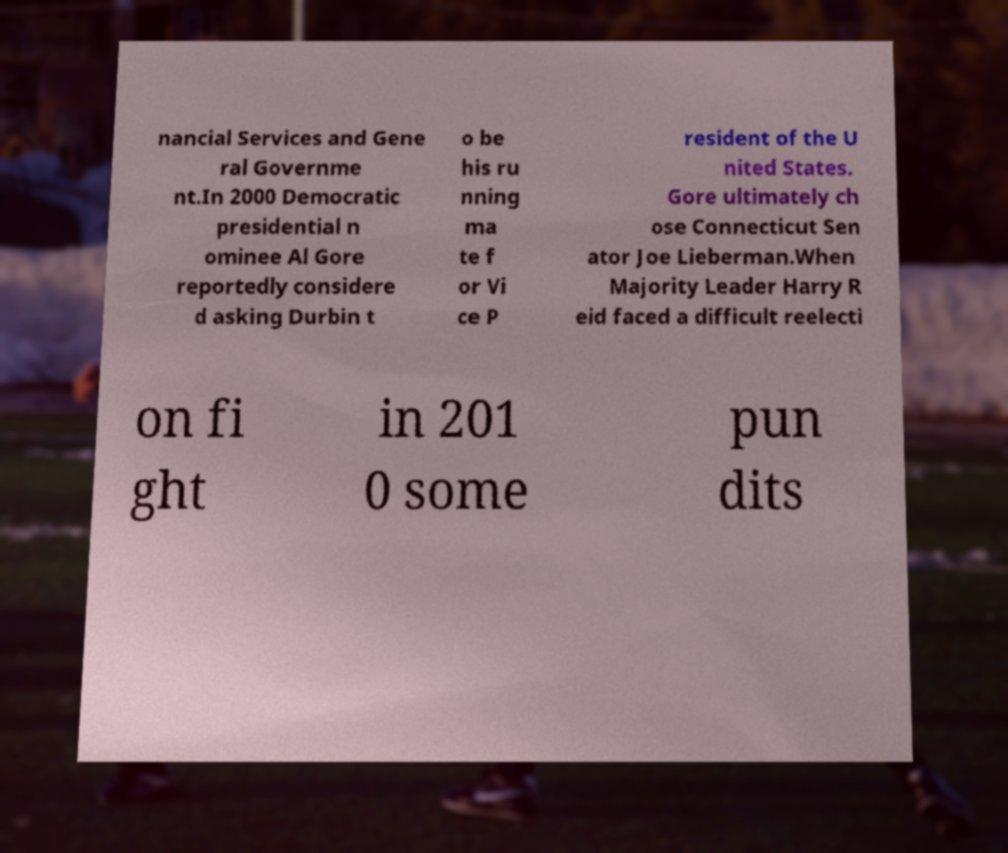Can you accurately transcribe the text from the provided image for me? nancial Services and Gene ral Governme nt.In 2000 Democratic presidential n ominee Al Gore reportedly considere d asking Durbin t o be his ru nning ma te f or Vi ce P resident of the U nited States. Gore ultimately ch ose Connecticut Sen ator Joe Lieberman.When Majority Leader Harry R eid faced a difficult reelecti on fi ght in 201 0 some pun dits 